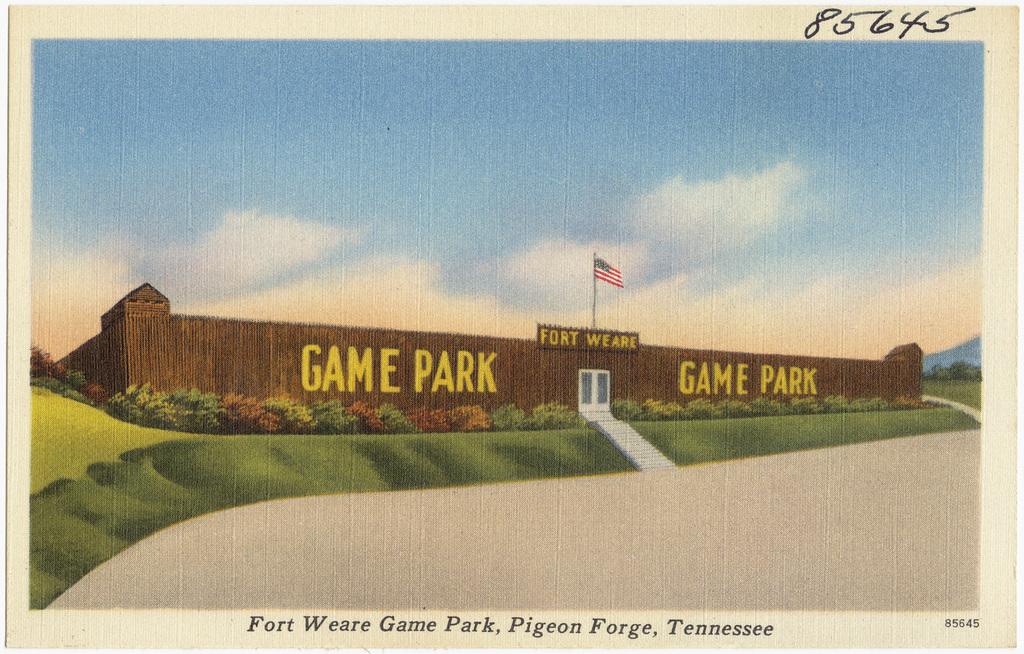What state is this in?
Keep it short and to the point. Tennessee. What kind of park is this?
Provide a short and direct response. Game park. 